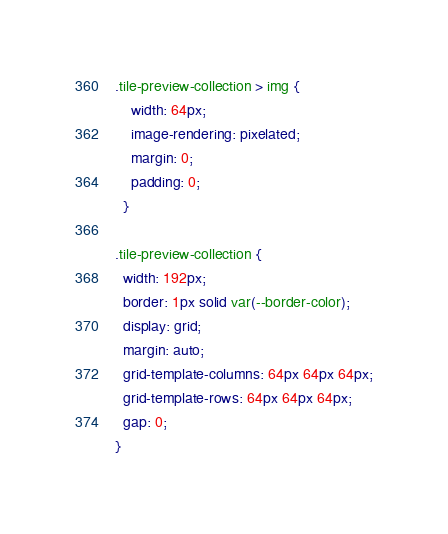Convert code to text. <code><loc_0><loc_0><loc_500><loc_500><_CSS_>.tile-preview-collection > img {
    width: 64px;
    image-rendering: pixelated;
    margin: 0;
    padding: 0;
  }
  
.tile-preview-collection {
  width: 192px; 
  border: 1px solid var(--border-color);
  display: grid;
  margin: auto;
  grid-template-columns: 64px 64px 64px;
  grid-template-rows: 64px 64px 64px;
  gap: 0;
}</code> 